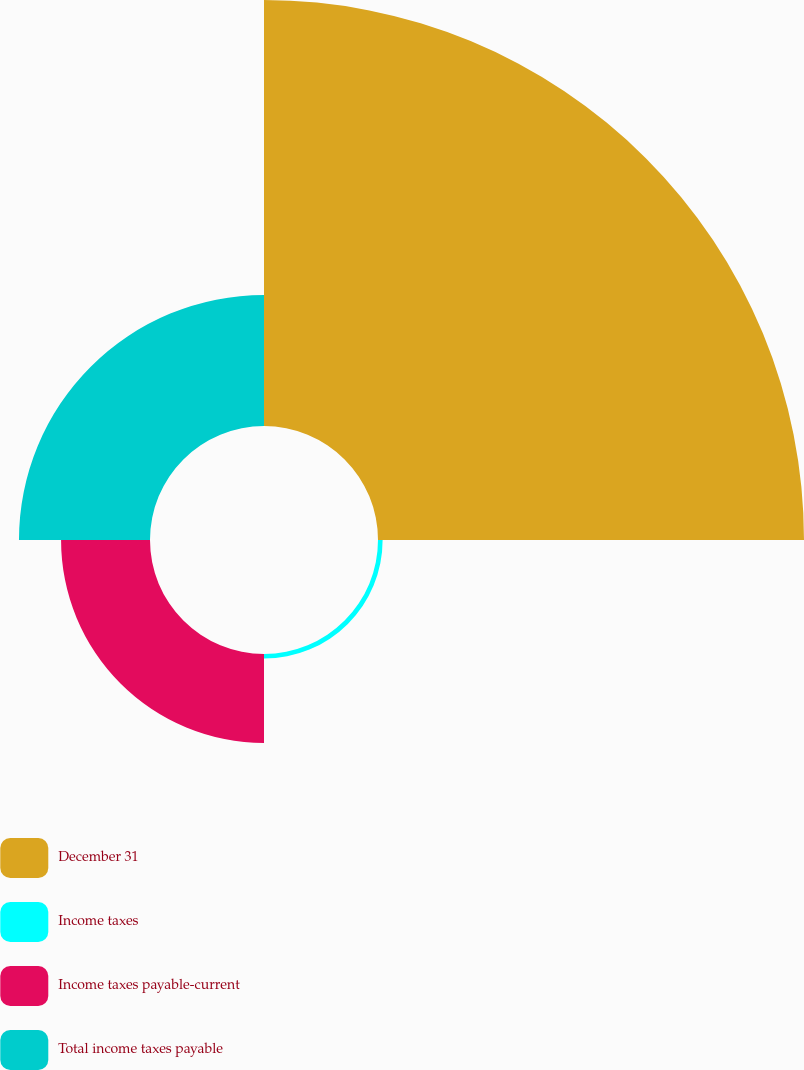Convert chart to OTSL. <chart><loc_0><loc_0><loc_500><loc_500><pie_chart><fcel>December 31<fcel>Income taxes<fcel>Income taxes payable-current<fcel>Total income taxes payable<nl><fcel>65.48%<fcel>0.71%<fcel>13.67%<fcel>20.14%<nl></chart> 